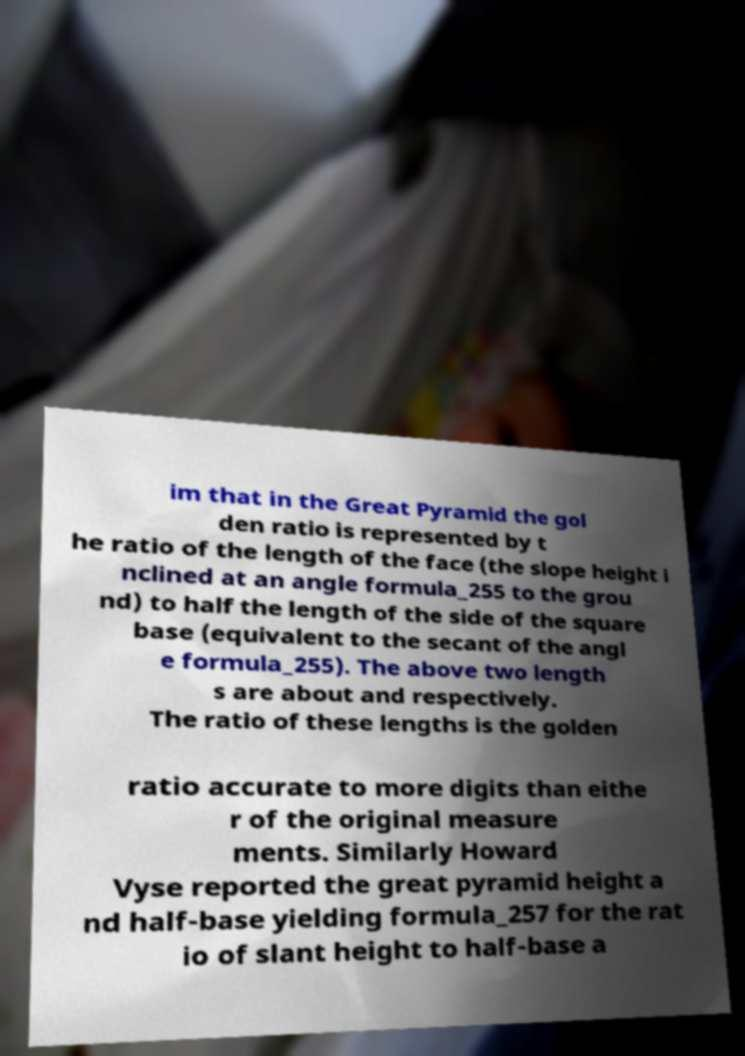I need the written content from this picture converted into text. Can you do that? im that in the Great Pyramid the gol den ratio is represented by t he ratio of the length of the face (the slope height i nclined at an angle formula_255 to the grou nd) to half the length of the side of the square base (equivalent to the secant of the angl e formula_255). The above two length s are about and respectively. The ratio of these lengths is the golden ratio accurate to more digits than eithe r of the original measure ments. Similarly Howard Vyse reported the great pyramid height a nd half-base yielding formula_257 for the rat io of slant height to half-base a 